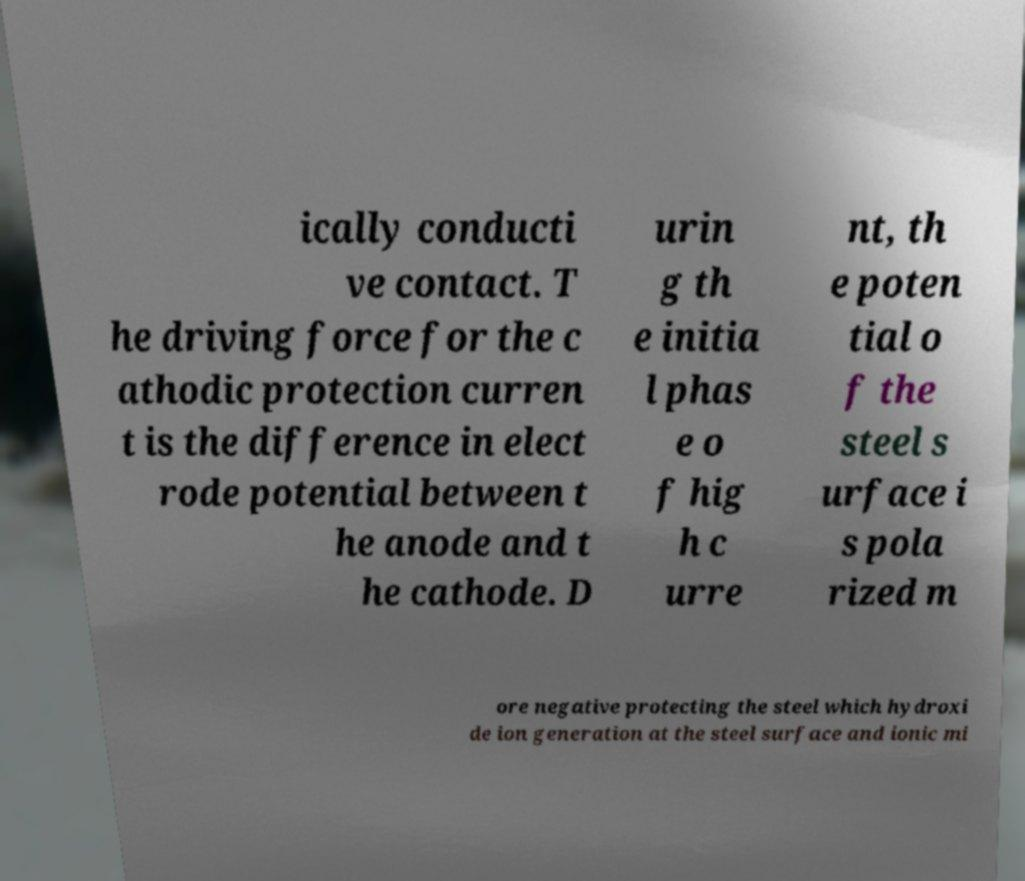Could you extract and type out the text from this image? ically conducti ve contact. T he driving force for the c athodic protection curren t is the difference in elect rode potential between t he anode and t he cathode. D urin g th e initia l phas e o f hig h c urre nt, th e poten tial o f the steel s urface i s pola rized m ore negative protecting the steel which hydroxi de ion generation at the steel surface and ionic mi 